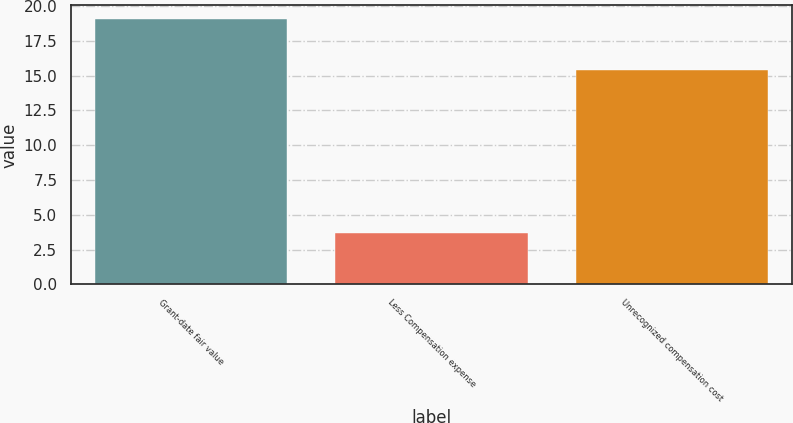Convert chart to OTSL. <chart><loc_0><loc_0><loc_500><loc_500><bar_chart><fcel>Grant-date fair value<fcel>Less Compensation expense<fcel>Unrecognized compensation cost<nl><fcel>19.1<fcel>3.7<fcel>15.4<nl></chart> 